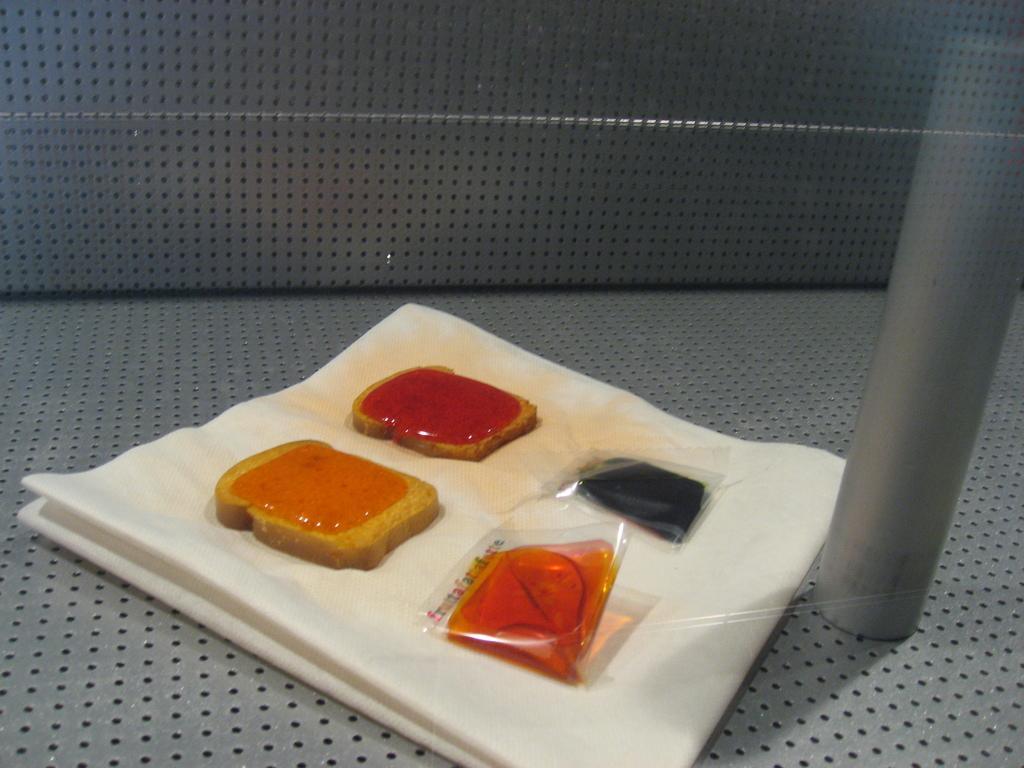What type of food is present in the image? There is bread jam and honey in the image. What else can be seen on the white cloth in the image? There are other objects on the white cloth, but their specific details are not mentioned in the provided facts. What can be seen in the background of the image? There is a couch visible in the background of the image. What type of berry is present on the line in the image? There is no berry or line present in the image. How many hydrants can be seen in the image? There are no hydrants visible in the image. 